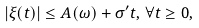<formula> <loc_0><loc_0><loc_500><loc_500>| \xi ( t ) | \leq A ( \omega ) + \sigma ^ { \prime } t , \, \forall t \geq 0 ,</formula> 